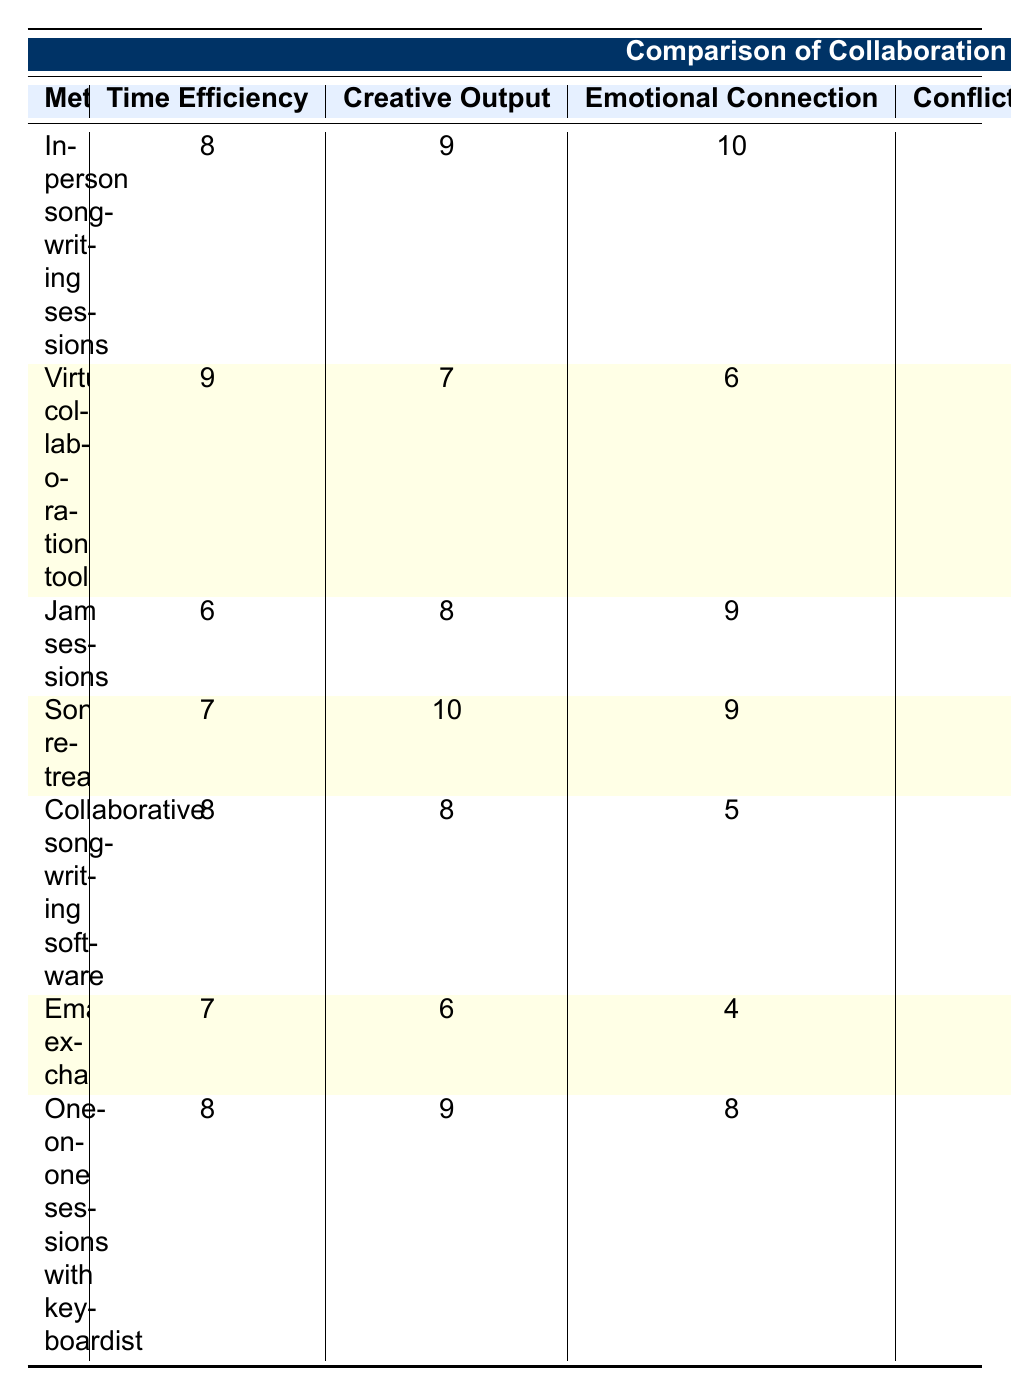What is the time efficiency rating for in-person songwriting sessions? The table shows that the time efficiency rating for in-person songwriting sessions is 8.
Answer: 8 Which method has the highest emotional connection score? The emotional connection scores are listed as follows: in-person songwriting sessions (10), jam sessions (9), songwriting retreats (9), one-on-one sessions with the keyboardist (8), virtual collaboration tools (6), collaborative songwriting software (5), and email exchanges (4). The highest score is from in-person songwriting sessions with a score of 10.
Answer: 10 Is virtual collaboration tools more flexible for scheduling compared to songwriting retreats? The flexibility for scheduling ratings are: virtual collaboration tools (10) and songwriting retreats (4). Since 10 is greater than 4, virtual collaboration tools are indeed more flexible for scheduling.
Answer: Yes What is the average creative output score for all methods? The creative output scores are as follows: 9 (in-person), 7 (virtual), 8 (jam), 10 (retreats), 8 (software), 6 (email), and 9 (one-on-one). To find the average: (9 + 7 + 8 + 10 + 8 + 6 + 9) / 7 = 57 / 7 = 8.14, approximately.
Answer: 8.14 Which collaboration method is the most cost-effective? The cost-effectiveness ratings are: 6 (in-person), 9 (virtual), 7 (jam), 5 (retreats), 8 (software), 10 (email), and 8 (one-on-one). The highest score of 10 belongs to email exchanges, making it the most cost-effective method.
Answer: Email exchanges 